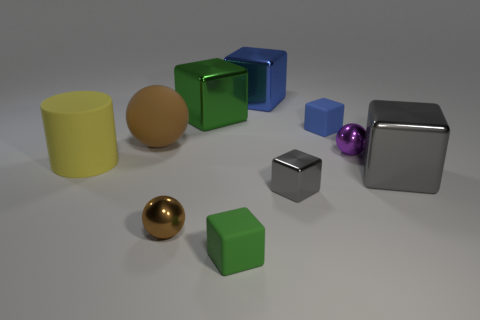Is there anything else that is the same shape as the large yellow rubber object?
Offer a terse response. No. What number of other objects are the same shape as the small gray thing?
Offer a very short reply. 5. What number of metal objects are large blue cylinders or big green blocks?
Offer a very short reply. 1. The green block in front of the brown object that is behind the rubber cylinder is made of what material?
Your answer should be very brief. Rubber. Are there more cubes that are behind the big gray metal cube than tiny brown objects?
Offer a terse response. Yes. Is there a tiny brown ball made of the same material as the large blue cube?
Provide a succinct answer. Yes. Is the shape of the rubber thing left of the big brown matte sphere the same as  the tiny purple thing?
Ensure brevity in your answer.  No. What number of big gray shiny blocks are right of the gray cube that is to the right of the gray metal object to the left of the blue rubber cube?
Give a very brief answer. 0. Is the number of yellow cylinders behind the matte sphere less than the number of small spheres to the right of the big gray metallic thing?
Provide a short and direct response. No. What is the color of the other tiny matte object that is the same shape as the tiny blue rubber thing?
Keep it short and to the point. Green. 